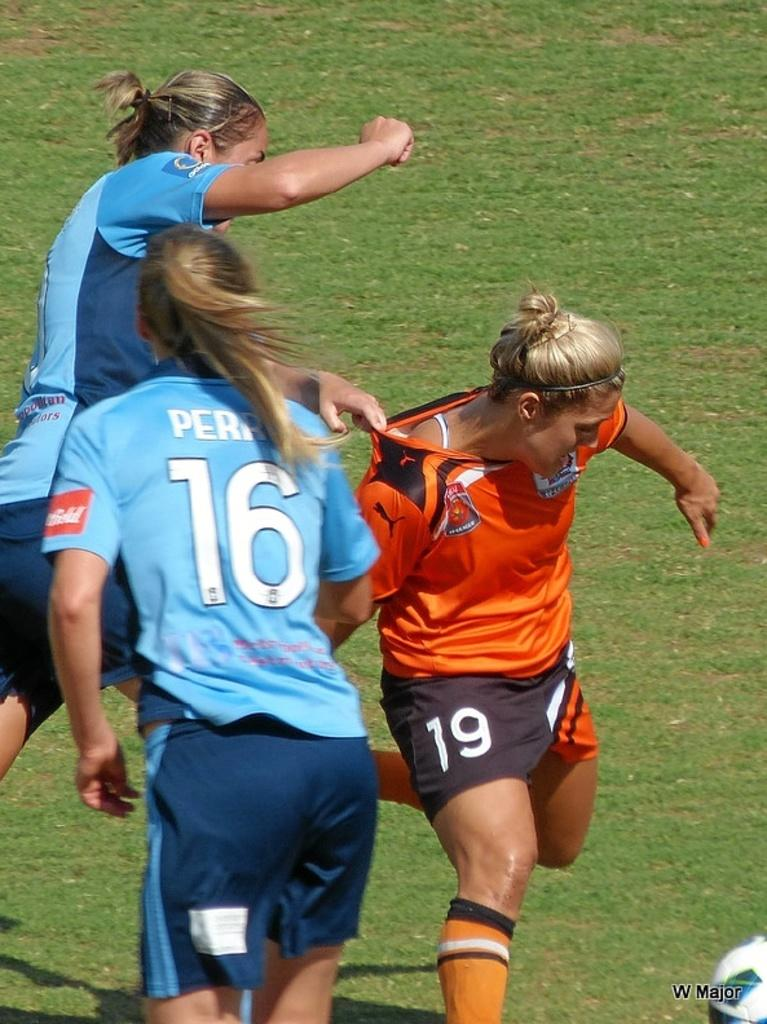<image>
Summarize the visual content of the image. A female soccer player with the number 16 on the back of her jersey. 